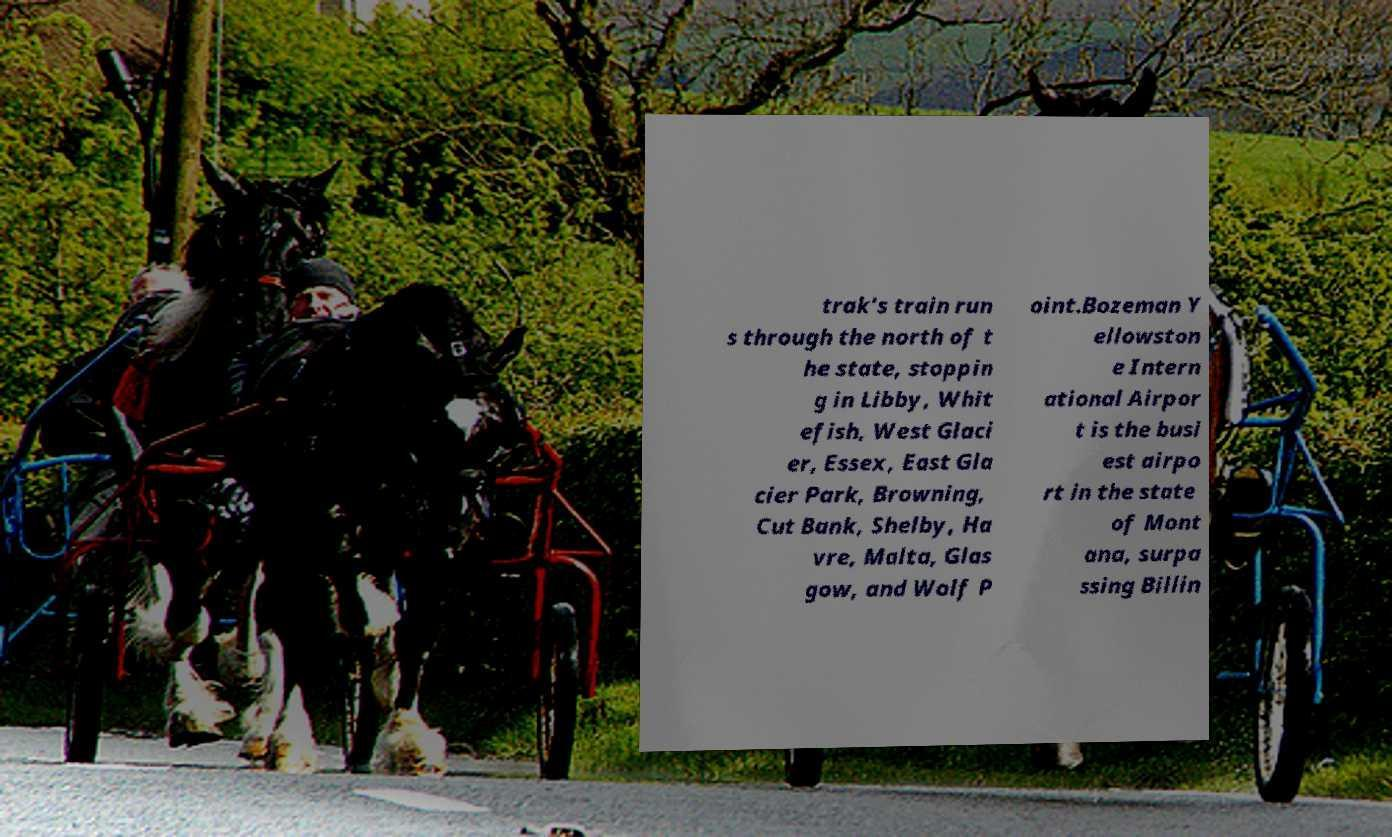Please identify and transcribe the text found in this image. trak's train run s through the north of t he state, stoppin g in Libby, Whit efish, West Glaci er, Essex, East Gla cier Park, Browning, Cut Bank, Shelby, Ha vre, Malta, Glas gow, and Wolf P oint.Bozeman Y ellowston e Intern ational Airpor t is the busi est airpo rt in the state of Mont ana, surpa ssing Billin 